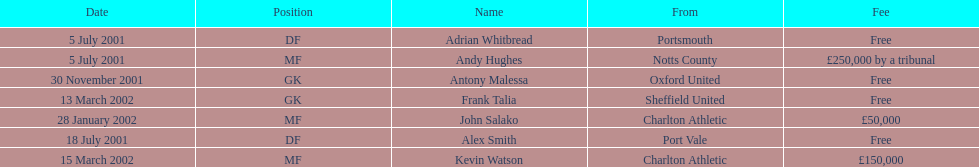Andy huges and adrian whitbread both tranfered on which date? 5 July 2001. 